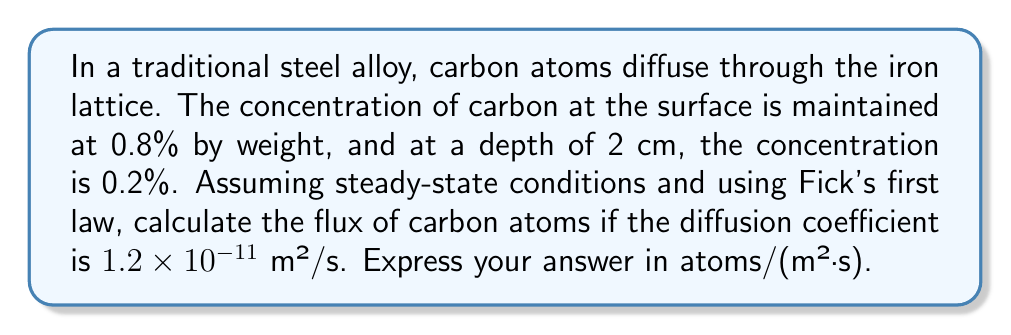Show me your answer to this math problem. Let's approach this problem step-by-step using Fick's first law:

1) Fick's first law in one dimension is given by:

   $$J = -D \frac{dC}{dx}$$

   where $J$ is the flux, $D$ is the diffusion coefficient, and $\frac{dC}{dx}$ is the concentration gradient.

2) We are given:
   - $D = 1.2 \times 10^{-11}$ m²/s
   - $C_1 = 0.8\%$ at $x_1 = 0$ cm
   - $C_2 = 0.2\%$ at $x_2 = 2$ cm

3) Calculate the concentration gradient:

   $$\frac{dC}{dx} = \frac{C_2 - C_1}{x_2 - x_1} = \frac{0.2\% - 0.8\%}{2\text{ cm} - 0\text{ cm}} = -0.3\%/\text{cm} = -30\%/\text{m}$$

4) Substitute into Fick's first law:

   $$J = -(1.2 \times 10^{-11} \text{ m²/s})(-30\%/\text{m}) = 3.6 \times 10^{-10} \%\text{·m/s}$$

5) Convert from weight percentage to atoms/m³:
   - Density of iron ≈ 7874 kg/m³
   - Atomic mass of carbon = 12 g/mol
   - Avogadro's number = $6.022 \times 10^{23}$ atoms/mol

   $$3.6 \times 10^{-10} \frac{\%\text{·m}}{\text{s}} \times \frac{7874 \text{ kg}}{\text{m}^3} \times \frac{1000 \text{ g}}{\text{kg}} \times \frac{\text{mol}}{12 \text{ g}} \times \frac{6.022 \times 10^{23} \text{ atoms}}{\text{mol}} \times \frac{1}{100\%}$$

6) Simplify:

   $$J \approx 1.42 \times 10^{18} \text{ atoms/(m²·s)}$$
Answer: $1.42 \times 10^{18}$ atoms/(m²·s) 